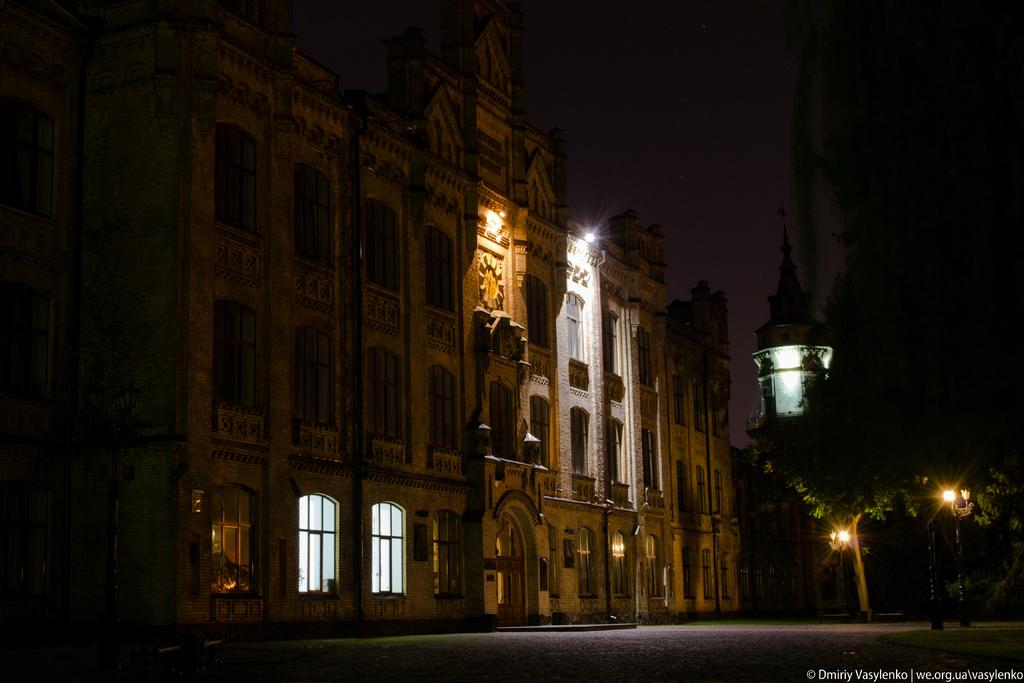What is the main structure in the image? There is a huge building in the image. What features can be seen on the building? The building has carvings. What is located in front of the building? There are many trees in front of the building. What type of illumination is present in front of the building? There are lights in front of the building. What type of seed is being planted by the father in the image? There is no father or seed present in the image; it only features a huge building with carvings, trees, and lights in front of it. 